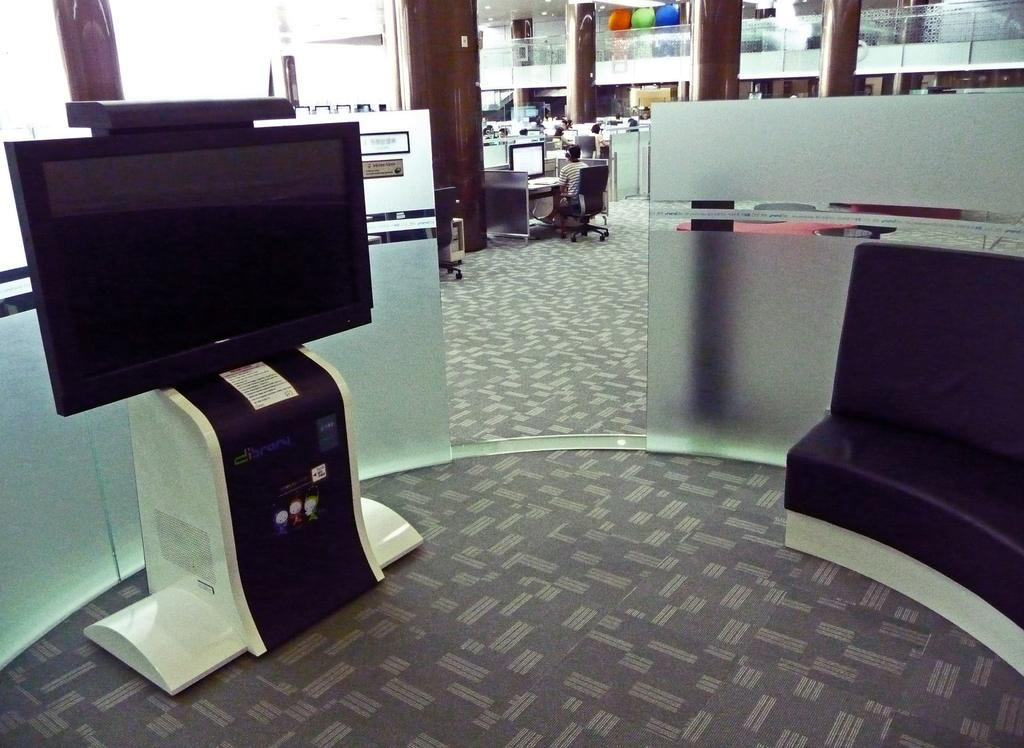What is the main object in the image? There is a machine in the image. What type of furniture is present in the image? There is a sofa on the floor in the image. Can you describe the person in the image? There is a person sitting on a chair in the background of the image. What can be seen through the walls in the background? There are glass walls in the background of the image. What architectural features are visible in the background? There are pillars in the background of the image. What electronic devices are present in the background? There are monitors in the background of the image. What safety feature is present in the background? There is a railing in the background of the image. What other objects can be seen in the background? There are some objects in the background of the image. How does the robin contribute to the functionality of the machine in the image? There is no robin present in the image, so it cannot contribute to the functionality of the machine. 